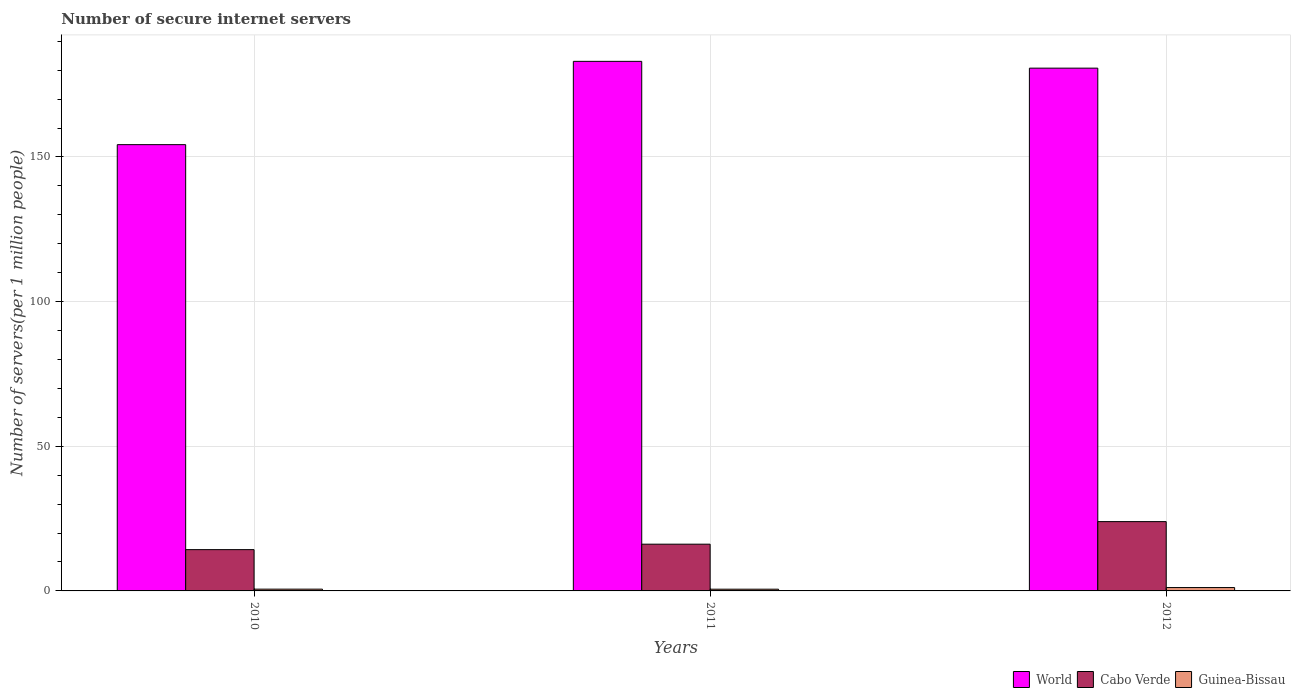Are the number of bars per tick equal to the number of legend labels?
Your answer should be very brief. Yes. What is the number of secure internet servers in World in 2010?
Your answer should be compact. 154.27. Across all years, what is the maximum number of secure internet servers in Guinea-Bissau?
Make the answer very short. 1.17. Across all years, what is the minimum number of secure internet servers in Guinea-Bissau?
Your answer should be compact. 0.6. In which year was the number of secure internet servers in Cabo Verde maximum?
Offer a very short reply. 2012. What is the total number of secure internet servers in World in the graph?
Your answer should be very brief. 518.04. What is the difference between the number of secure internet servers in Guinea-Bissau in 2011 and that in 2012?
Ensure brevity in your answer.  -0.57. What is the difference between the number of secure internet servers in World in 2011 and the number of secure internet servers in Guinea-Bissau in 2010?
Make the answer very short. 182.45. What is the average number of secure internet servers in Guinea-Bissau per year?
Ensure brevity in your answer.  0.79. In the year 2011, what is the difference between the number of secure internet servers in Cabo Verde and number of secure internet servers in Guinea-Bissau?
Keep it short and to the point. 15.56. What is the ratio of the number of secure internet servers in Cabo Verde in 2010 to that in 2011?
Provide a succinct answer. 0.88. What is the difference between the highest and the second highest number of secure internet servers in Cabo Verde?
Make the answer very short. 7.8. What is the difference between the highest and the lowest number of secure internet servers in Guinea-Bissau?
Your answer should be very brief. 0.57. In how many years, is the number of secure internet servers in World greater than the average number of secure internet servers in World taken over all years?
Offer a terse response. 2. What does the 2nd bar from the right in 2012 represents?
Provide a short and direct response. Cabo Verde. How many bars are there?
Your answer should be very brief. 9. Are all the bars in the graph horizontal?
Give a very brief answer. No. Are the values on the major ticks of Y-axis written in scientific E-notation?
Provide a succinct answer. No. Does the graph contain any zero values?
Offer a very short reply. No. Where does the legend appear in the graph?
Your response must be concise. Bottom right. How many legend labels are there?
Give a very brief answer. 3. What is the title of the graph?
Your response must be concise. Number of secure internet servers. Does "Lesotho" appear as one of the legend labels in the graph?
Your answer should be compact. No. What is the label or title of the Y-axis?
Give a very brief answer. Number of servers(per 1 million people). What is the Number of servers(per 1 million people) of World in 2010?
Provide a short and direct response. 154.27. What is the Number of servers(per 1 million people) of Cabo Verde in 2010?
Your answer should be compact. 14.27. What is the Number of servers(per 1 million people) in Guinea-Bissau in 2010?
Ensure brevity in your answer.  0.61. What is the Number of servers(per 1 million people) of World in 2011?
Provide a short and direct response. 183.06. What is the Number of servers(per 1 million people) in Cabo Verde in 2011?
Provide a short and direct response. 16.16. What is the Number of servers(per 1 million people) of Guinea-Bissau in 2011?
Your answer should be very brief. 0.6. What is the Number of servers(per 1 million people) of World in 2012?
Ensure brevity in your answer.  180.71. What is the Number of servers(per 1 million people) of Cabo Verde in 2012?
Give a very brief answer. 23.96. What is the Number of servers(per 1 million people) in Guinea-Bissau in 2012?
Make the answer very short. 1.17. Across all years, what is the maximum Number of servers(per 1 million people) in World?
Make the answer very short. 183.06. Across all years, what is the maximum Number of servers(per 1 million people) of Cabo Verde?
Your response must be concise. 23.96. Across all years, what is the maximum Number of servers(per 1 million people) in Guinea-Bissau?
Offer a terse response. 1.17. Across all years, what is the minimum Number of servers(per 1 million people) in World?
Give a very brief answer. 154.27. Across all years, what is the minimum Number of servers(per 1 million people) in Cabo Verde?
Offer a very short reply. 14.27. Across all years, what is the minimum Number of servers(per 1 million people) of Guinea-Bissau?
Provide a succinct answer. 0.6. What is the total Number of servers(per 1 million people) in World in the graph?
Give a very brief answer. 518.04. What is the total Number of servers(per 1 million people) of Cabo Verde in the graph?
Provide a short and direct response. 54.39. What is the total Number of servers(per 1 million people) in Guinea-Bissau in the graph?
Offer a terse response. 2.38. What is the difference between the Number of servers(per 1 million people) of World in 2010 and that in 2011?
Provide a succinct answer. -28.79. What is the difference between the Number of servers(per 1 million people) in Cabo Verde in 2010 and that in 2011?
Your answer should be compact. -1.88. What is the difference between the Number of servers(per 1 million people) in Guinea-Bissau in 2010 and that in 2011?
Offer a very short reply. 0.01. What is the difference between the Number of servers(per 1 million people) of World in 2010 and that in 2012?
Provide a succinct answer. -26.45. What is the difference between the Number of servers(per 1 million people) of Cabo Verde in 2010 and that in 2012?
Keep it short and to the point. -9.68. What is the difference between the Number of servers(per 1 million people) in Guinea-Bissau in 2010 and that in 2012?
Provide a short and direct response. -0.55. What is the difference between the Number of servers(per 1 million people) in World in 2011 and that in 2012?
Offer a very short reply. 2.35. What is the difference between the Number of servers(per 1 million people) in Cabo Verde in 2011 and that in 2012?
Make the answer very short. -7.8. What is the difference between the Number of servers(per 1 million people) of Guinea-Bissau in 2011 and that in 2012?
Offer a terse response. -0.57. What is the difference between the Number of servers(per 1 million people) of World in 2010 and the Number of servers(per 1 million people) of Cabo Verde in 2011?
Give a very brief answer. 138.11. What is the difference between the Number of servers(per 1 million people) of World in 2010 and the Number of servers(per 1 million people) of Guinea-Bissau in 2011?
Offer a terse response. 153.67. What is the difference between the Number of servers(per 1 million people) in Cabo Verde in 2010 and the Number of servers(per 1 million people) in Guinea-Bissau in 2011?
Keep it short and to the point. 13.68. What is the difference between the Number of servers(per 1 million people) of World in 2010 and the Number of servers(per 1 million people) of Cabo Verde in 2012?
Your response must be concise. 130.31. What is the difference between the Number of servers(per 1 million people) of World in 2010 and the Number of servers(per 1 million people) of Guinea-Bissau in 2012?
Your response must be concise. 153.1. What is the difference between the Number of servers(per 1 million people) in Cabo Verde in 2010 and the Number of servers(per 1 million people) in Guinea-Bissau in 2012?
Offer a very short reply. 13.11. What is the difference between the Number of servers(per 1 million people) of World in 2011 and the Number of servers(per 1 million people) of Cabo Verde in 2012?
Provide a succinct answer. 159.1. What is the difference between the Number of servers(per 1 million people) in World in 2011 and the Number of servers(per 1 million people) in Guinea-Bissau in 2012?
Make the answer very short. 181.89. What is the difference between the Number of servers(per 1 million people) in Cabo Verde in 2011 and the Number of servers(per 1 million people) in Guinea-Bissau in 2012?
Offer a terse response. 14.99. What is the average Number of servers(per 1 million people) in World per year?
Provide a succinct answer. 172.68. What is the average Number of servers(per 1 million people) in Cabo Verde per year?
Offer a terse response. 18.13. What is the average Number of servers(per 1 million people) in Guinea-Bissau per year?
Make the answer very short. 0.79. In the year 2010, what is the difference between the Number of servers(per 1 million people) in World and Number of servers(per 1 million people) in Cabo Verde?
Offer a terse response. 139.99. In the year 2010, what is the difference between the Number of servers(per 1 million people) of World and Number of servers(per 1 million people) of Guinea-Bissau?
Give a very brief answer. 153.65. In the year 2010, what is the difference between the Number of servers(per 1 million people) of Cabo Verde and Number of servers(per 1 million people) of Guinea-Bissau?
Keep it short and to the point. 13.66. In the year 2011, what is the difference between the Number of servers(per 1 million people) in World and Number of servers(per 1 million people) in Cabo Verde?
Offer a terse response. 166.9. In the year 2011, what is the difference between the Number of servers(per 1 million people) of World and Number of servers(per 1 million people) of Guinea-Bissau?
Provide a short and direct response. 182.46. In the year 2011, what is the difference between the Number of servers(per 1 million people) of Cabo Verde and Number of servers(per 1 million people) of Guinea-Bissau?
Provide a short and direct response. 15.56. In the year 2012, what is the difference between the Number of servers(per 1 million people) in World and Number of servers(per 1 million people) in Cabo Verde?
Provide a short and direct response. 156.75. In the year 2012, what is the difference between the Number of servers(per 1 million people) in World and Number of servers(per 1 million people) in Guinea-Bissau?
Your response must be concise. 179.55. In the year 2012, what is the difference between the Number of servers(per 1 million people) of Cabo Verde and Number of servers(per 1 million people) of Guinea-Bissau?
Provide a succinct answer. 22.79. What is the ratio of the Number of servers(per 1 million people) of World in 2010 to that in 2011?
Ensure brevity in your answer.  0.84. What is the ratio of the Number of servers(per 1 million people) of Cabo Verde in 2010 to that in 2011?
Your answer should be compact. 0.88. What is the ratio of the Number of servers(per 1 million people) in Guinea-Bissau in 2010 to that in 2011?
Ensure brevity in your answer.  1.02. What is the ratio of the Number of servers(per 1 million people) of World in 2010 to that in 2012?
Your answer should be very brief. 0.85. What is the ratio of the Number of servers(per 1 million people) of Cabo Verde in 2010 to that in 2012?
Give a very brief answer. 0.6. What is the ratio of the Number of servers(per 1 million people) of Guinea-Bissau in 2010 to that in 2012?
Your answer should be compact. 0.52. What is the ratio of the Number of servers(per 1 million people) of World in 2011 to that in 2012?
Offer a very short reply. 1.01. What is the ratio of the Number of servers(per 1 million people) of Cabo Verde in 2011 to that in 2012?
Give a very brief answer. 0.67. What is the ratio of the Number of servers(per 1 million people) of Guinea-Bissau in 2011 to that in 2012?
Your answer should be compact. 0.51. What is the difference between the highest and the second highest Number of servers(per 1 million people) of World?
Your answer should be very brief. 2.35. What is the difference between the highest and the second highest Number of servers(per 1 million people) in Cabo Verde?
Provide a short and direct response. 7.8. What is the difference between the highest and the second highest Number of servers(per 1 million people) in Guinea-Bissau?
Provide a succinct answer. 0.55. What is the difference between the highest and the lowest Number of servers(per 1 million people) of World?
Keep it short and to the point. 28.79. What is the difference between the highest and the lowest Number of servers(per 1 million people) in Cabo Verde?
Your answer should be compact. 9.68. What is the difference between the highest and the lowest Number of servers(per 1 million people) of Guinea-Bissau?
Keep it short and to the point. 0.57. 